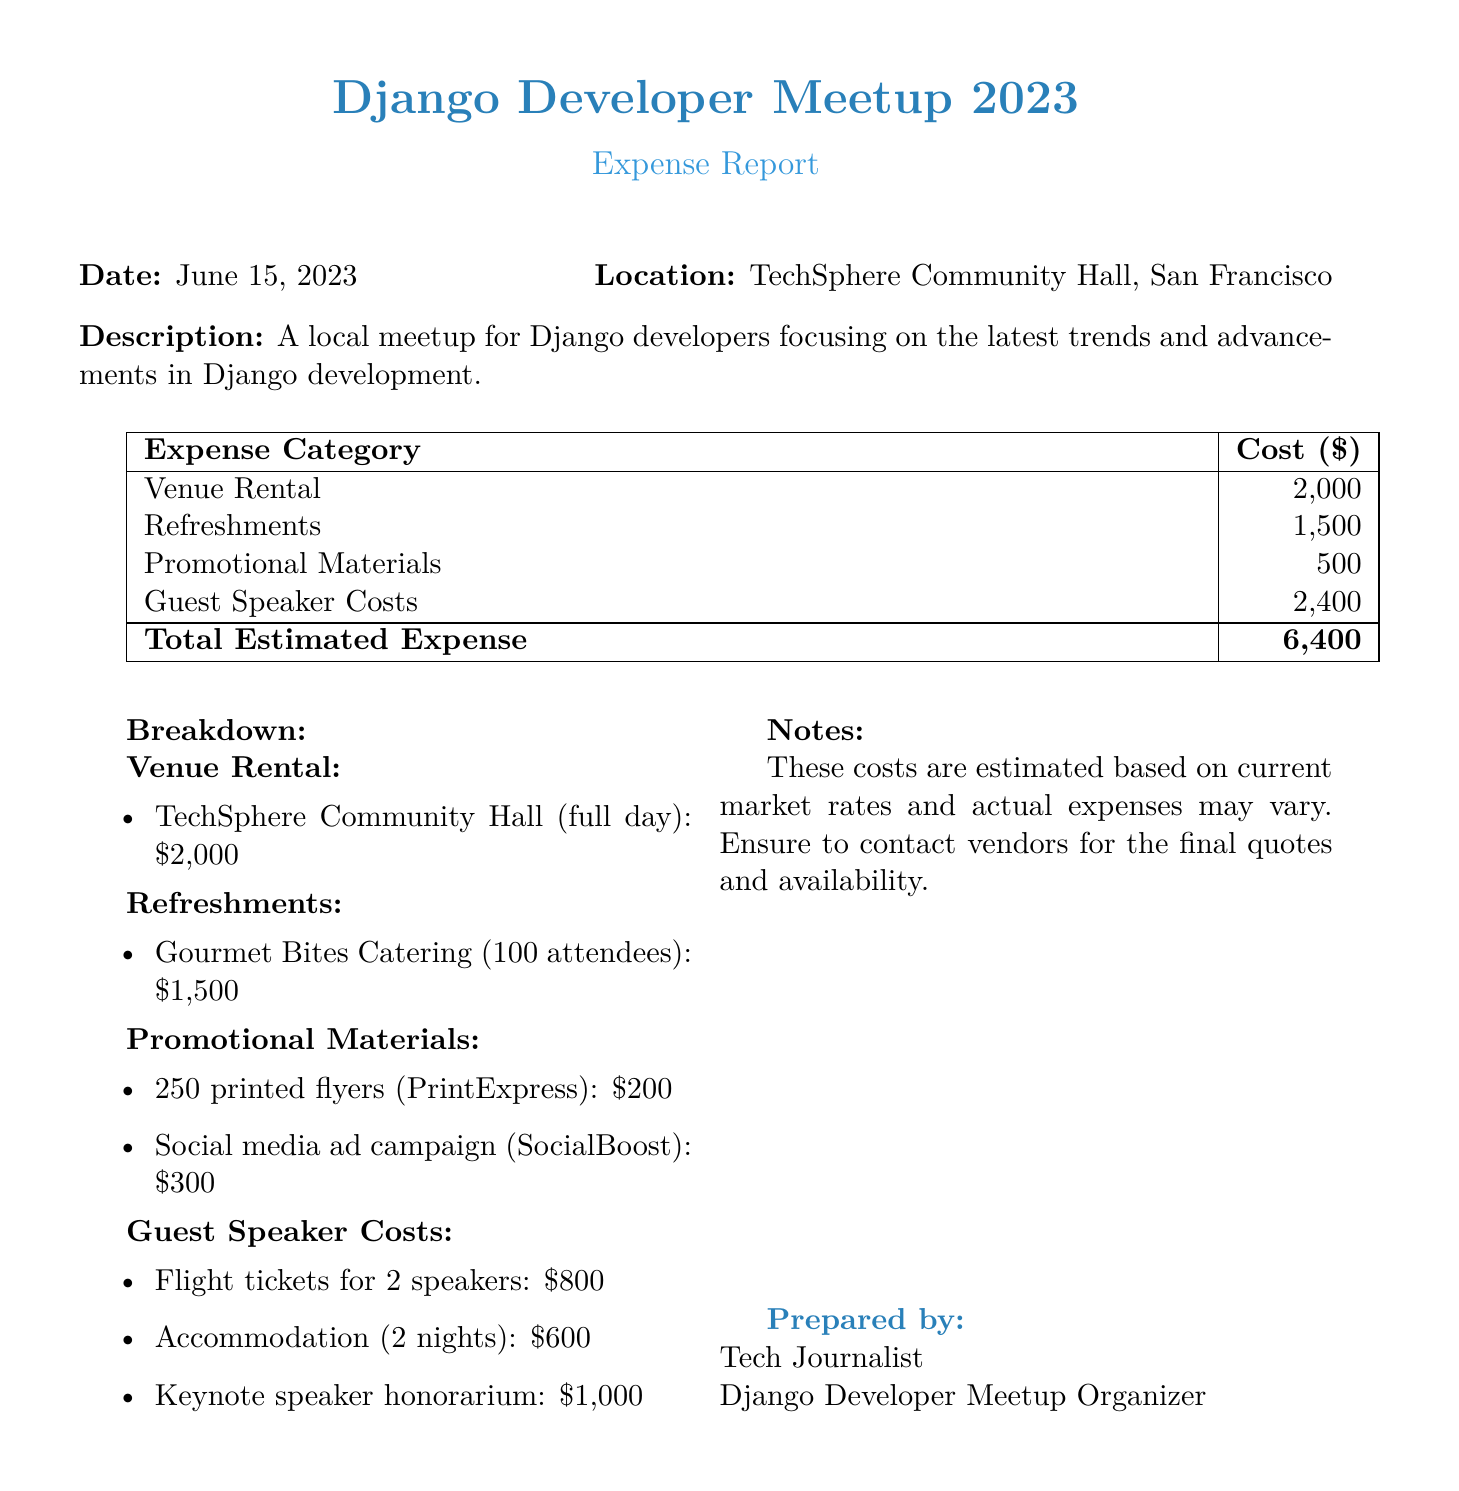What is the date of the event? The date is specifically mentioned in the document.
Answer: June 15, 2023 What is the total estimated expense? The total estimated expense is provided at the bottom of the expense table.
Answer: 6,400 How much did the venue rental cost? The cost for venue rental is listed separately in the expenses section.
Answer: 2,000 What is the cost for refreshments? The expense for refreshments is also detailed in the document.
Answer: 1,500 How many attendees were catered for refreshments? The number of attendees catered for is specified in the breakdown of refreshments.
Answer: 100 What is included in the promotional materials cost? The promotional materials cost is broken down into two specific items.
Answer: 250 printed flyers and social media ad campaign How many nights did the guest speakers stay? The accommodation information for guest speakers mentions a specific duration.
Answer: 2 nights Who prepared the expense report? The document mentions who prepared it at the end.
Answer: Tech Journalist What was the honorarium for the keynote speaker? The guest speaker costs include the honorarium mentioned specifically.
Answer: 1,000 